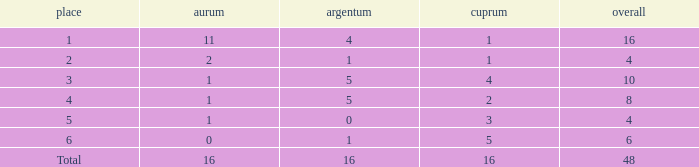How many gold are a rank 1 and larger than 16? 0.0. 